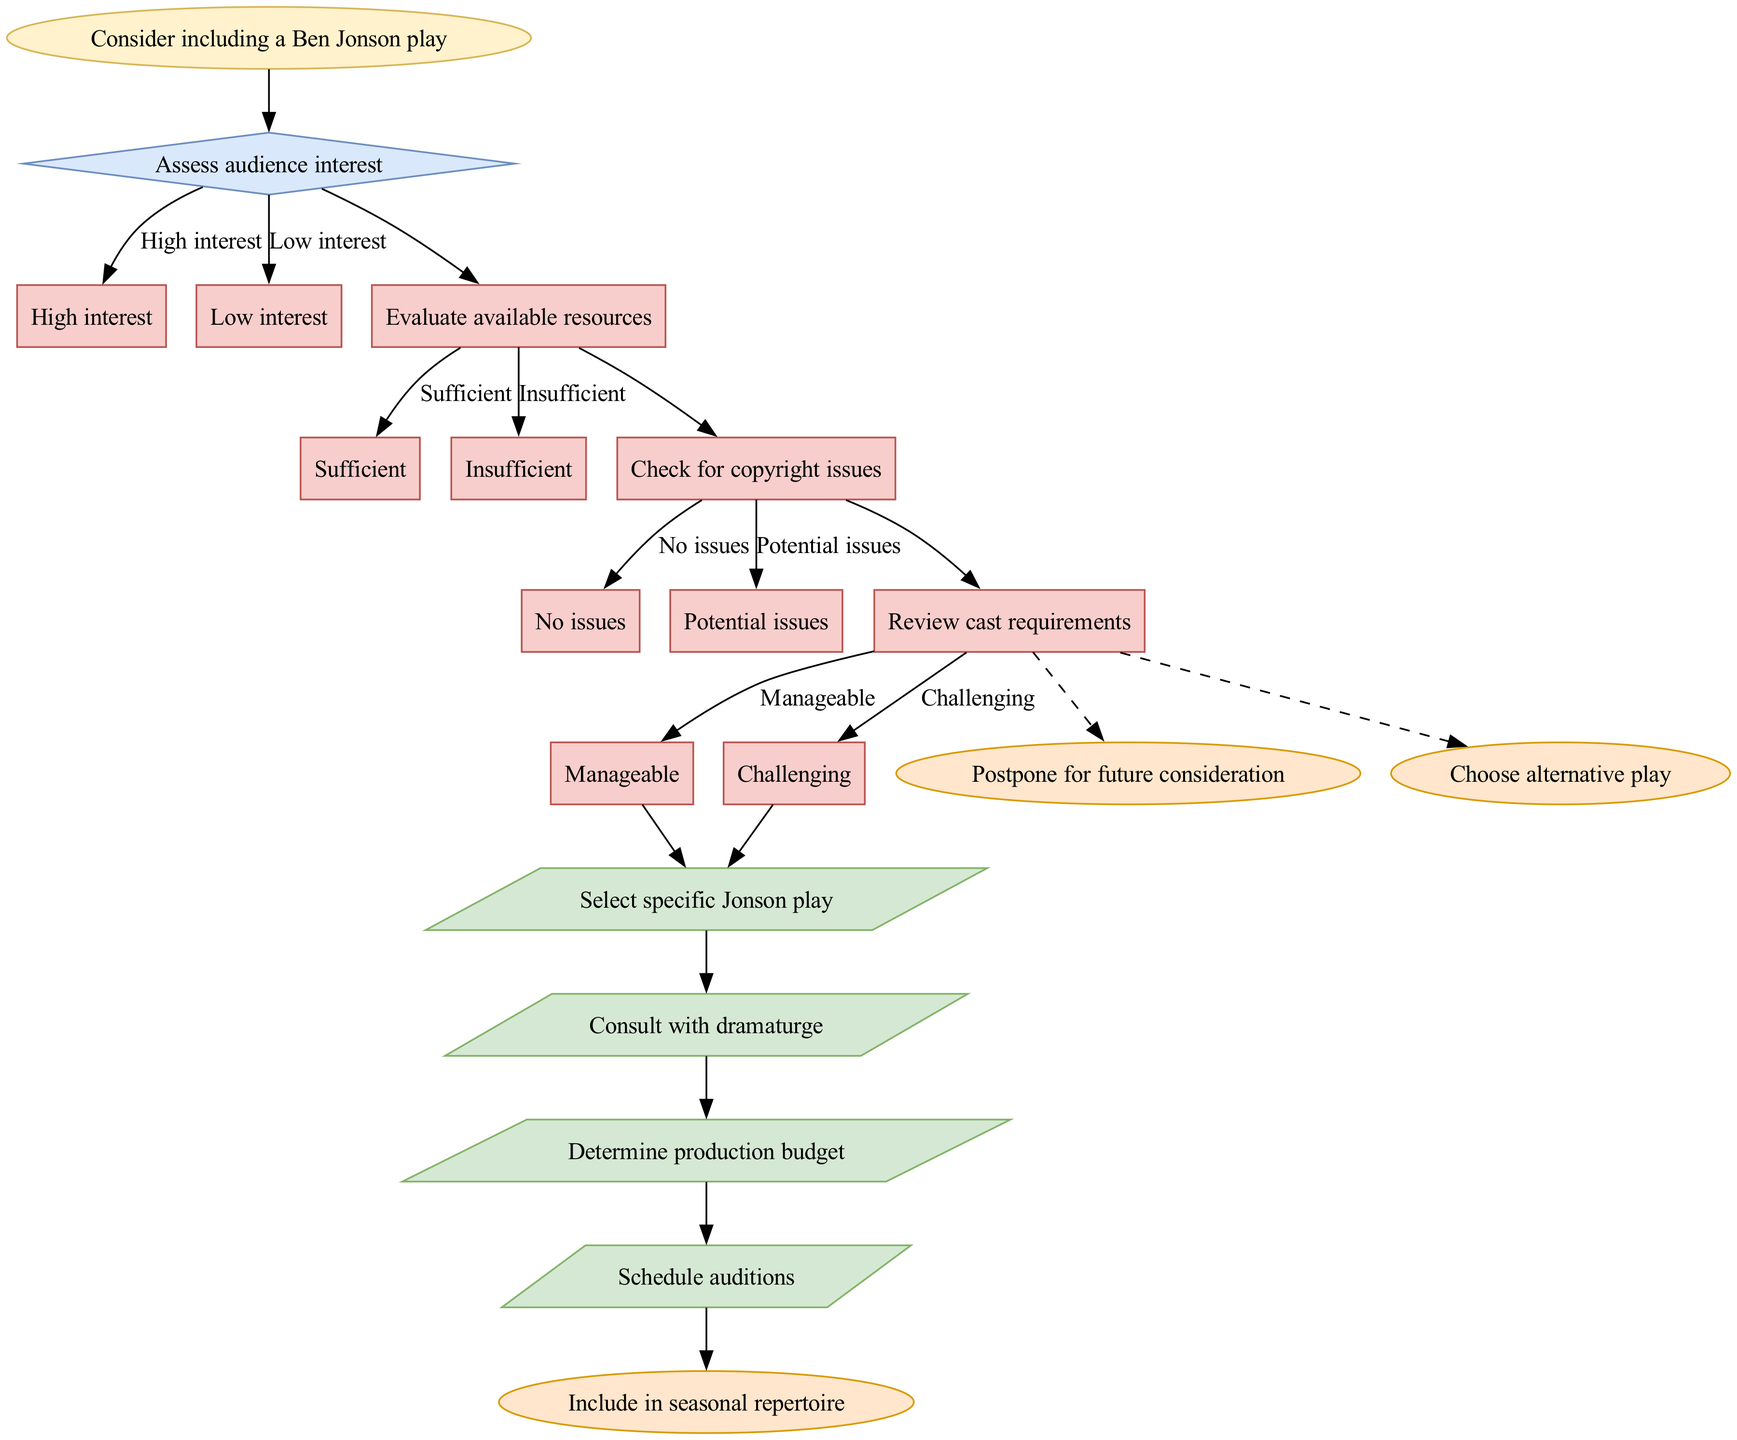What is the starting point of the decision-making process? The diagram begins with the node labeled "Consider including a Ben Jonson play," which indicates the starting point of the entire process.
Answer: Consider including a Ben Jonson play How many decision nodes are present in the diagram? The diagram contains four decision nodes: "Assess audience interest," "Evaluate available resources," "Check for copyright issues," and "Review cast requirements." Therefore, there are four decision nodes in total.
Answer: 4 What action follows after a manageable cast requirement? After reaching the option "Manageable" in the "Review cast requirements" decision node, the next action taken is to "Select specific Jonson play."
Answer: Select specific Jonson play If audience interest is low, which outcome is possible? From the decision "Assess audience interest" with the option "Low interest," the pathway leads to a dashed edge that directs towards the outcome "Choose alternative play," indicating that if the interest is low, that is an outcome.
Answer: Choose alternative play What action is taken after determining sufficient resources? After determining "Sufficient" resources in the decision "Evaluate available resources," the subsequent action that is taken is to "Consult with dramaturge."
Answer: Consult with dramaturge Which decision node is followed by a copyright check? The decision "Check for copyright issues" follows the node "Evaluate available resources," as it is the next step in the decision-making process concerning the play inclusion.
Answer: Check for copyright issues How does the flow progress from checking copyright issues? After checking for copyright issues, if there are "No issues," it leads directly to scheduling auditions, connecting to the next action, but if there are "Potential issues," it connects through a dashed edge to postpone the consideration.
Answer: Schedule auditions or postpone for future consideration What happens if the cast requirements are found to be challenging? If the cast requirements are too "Challenging," the diagram indicates a dashed edge towards the outcome "Postpone for future consideration," indicating that this is a potential outcome when facing this challenge.
Answer: Postpone for future consideration 